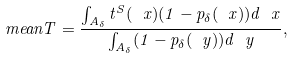<formula> <loc_0><loc_0><loc_500><loc_500>\ m e a n { T } = \frac { \int _ { A _ { \delta } } t ^ { S } ( \ x ) ( 1 - p _ { \delta } ( \ x ) ) d \ x } { \int _ { A _ { \delta } } ( 1 - p _ { \delta } ( \ y ) ) d \ y } ,</formula> 